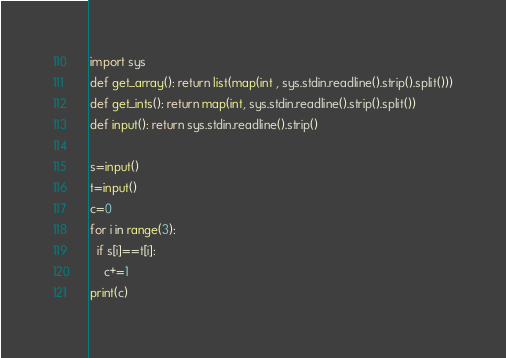Convert code to text. <code><loc_0><loc_0><loc_500><loc_500><_Python_>import sys
def get_array(): return list(map(int , sys.stdin.readline().strip().split()))
def get_ints(): return map(int, sys.stdin.readline().strip().split())
def input(): return sys.stdin.readline().strip()

s=input()
t=input()
c=0
for i in range(3):
  if s[i]==t[i]:
    c+=1
print(c)</code> 